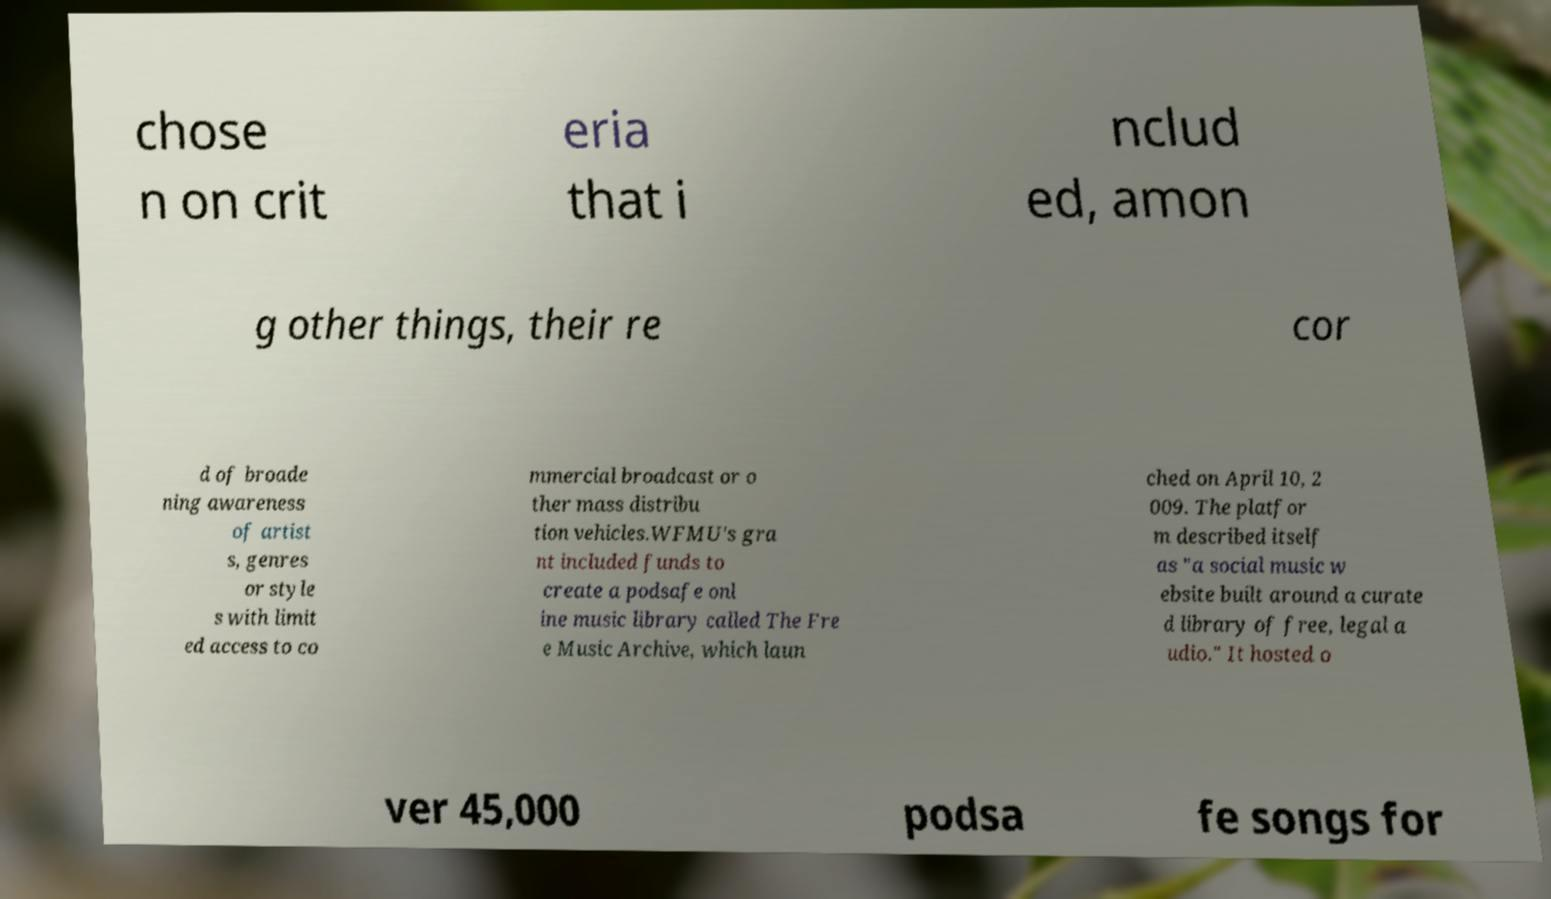Please read and relay the text visible in this image. What does it say? chose n on crit eria that i nclud ed, amon g other things, their re cor d of broade ning awareness of artist s, genres or style s with limit ed access to co mmercial broadcast or o ther mass distribu tion vehicles.WFMU's gra nt included funds to create a podsafe onl ine music library called The Fre e Music Archive, which laun ched on April 10, 2 009. The platfor m described itself as "a social music w ebsite built around a curate d library of free, legal a udio." It hosted o ver 45,000 podsa fe songs for 